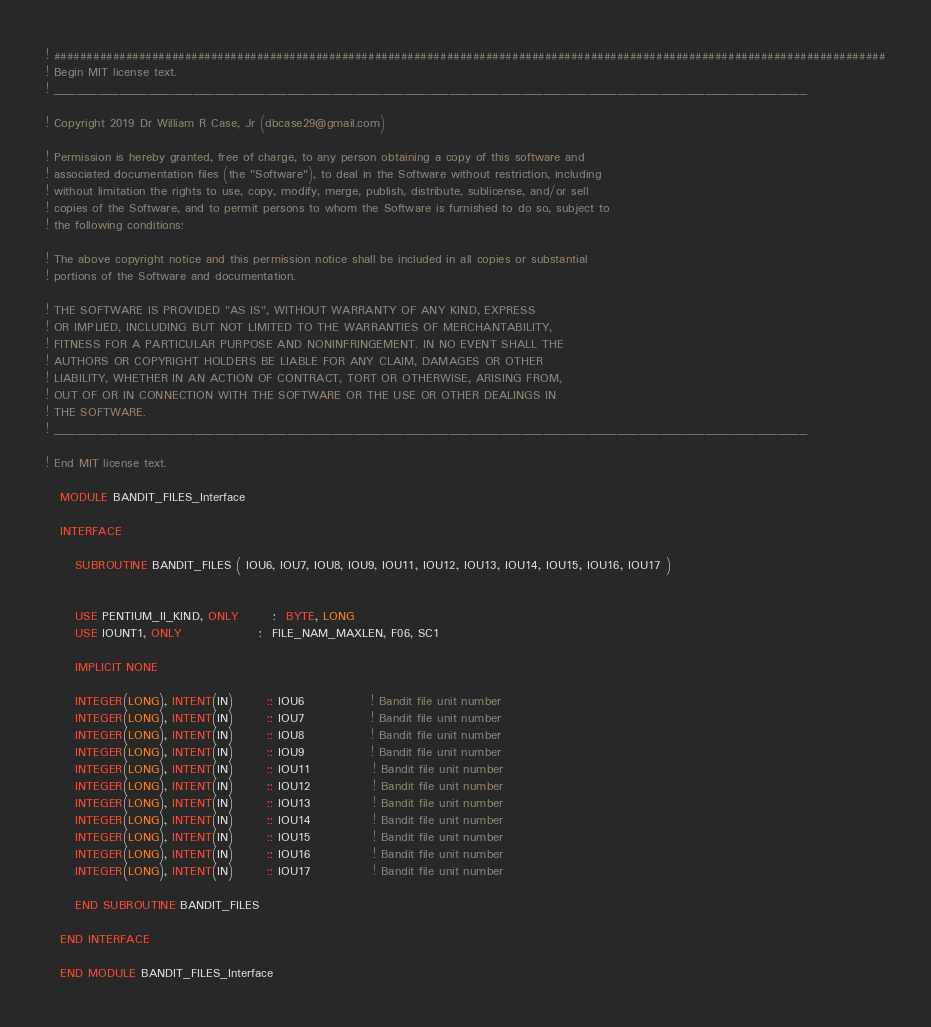Convert code to text. <code><loc_0><loc_0><loc_500><loc_500><_FORTRAN_>! ###############################################################################################################################
! Begin MIT license text.                                                                                    
! _______________________________________________________________________________________________________
                                                                                                         
! Copyright 2019 Dr William R Case, Jr (dbcase29@gmail.com)                                              
                                                                                                         
! Permission is hereby granted, free of charge, to any person obtaining a copy of this software and      
! associated documentation files (the "Software"), to deal in the Software without restriction, including
! without limitation the rights to use, copy, modify, merge, publish, distribute, sublicense, and/or sell
! copies of the Software, and to permit persons to whom the Software is furnished to do so, subject to   
! the following conditions:                                                                              
                                                                                                         
! The above copyright notice and this permission notice shall be included in all copies or substantial   
! portions of the Software and documentation.                                                                              
                                                                                                         
! THE SOFTWARE IS PROVIDED "AS IS", WITHOUT WARRANTY OF ANY KIND, EXPRESS                                
! OR IMPLIED, INCLUDING BUT NOT LIMITED TO THE WARRANTIES OF MERCHANTABILITY,                            
! FITNESS FOR A PARTICULAR PURPOSE AND NONINFRINGEMENT. IN NO EVENT SHALL THE                            
! AUTHORS OR COPYRIGHT HOLDERS BE LIABLE FOR ANY CLAIM, DAMAGES OR OTHER                                 
! LIABILITY, WHETHER IN AN ACTION OF CONTRACT, TORT OR OTHERWISE, ARISING FROM,                          
! OUT OF OR IN CONNECTION WITH THE SOFTWARE OR THE USE OR OTHER DEALINGS IN                              
! THE SOFTWARE.                                                                                          
! _______________________________________________________________________________________________________
                                                                                                        
! End MIT license text.                                                                                      

   MODULE BANDIT_FILES_Interface

   INTERFACE

      SUBROUTINE BANDIT_FILES ( IOU6, IOU7, IOU8, IOU9, IOU11, IOU12, IOU13, IOU14, IOU15, IOU16, IOU17 )

 
      USE PENTIUM_II_KIND, ONLY       :  BYTE, LONG
      USE IOUNT1, ONLY                :  FILE_NAM_MAXLEN, F06, SC1

      IMPLICIT NONE
 
      INTEGER(LONG), INTENT(IN)       :: IOU6              ! Bandit file unit number
      INTEGER(LONG), INTENT(IN)       :: IOU7              ! Bandit file unit number
      INTEGER(LONG), INTENT(IN)       :: IOU8              ! Bandit file unit number
      INTEGER(LONG), INTENT(IN)       :: IOU9              ! Bandit file unit number
      INTEGER(LONG), INTENT(IN)       :: IOU11             ! Bandit file unit number
      INTEGER(LONG), INTENT(IN)       :: IOU12             ! Bandit file unit number
      INTEGER(LONG), INTENT(IN)       :: IOU13             ! Bandit file unit number
      INTEGER(LONG), INTENT(IN)       :: IOU14             ! Bandit file unit number
      INTEGER(LONG), INTENT(IN)       :: IOU15             ! Bandit file unit number
      INTEGER(LONG), INTENT(IN)       :: IOU16             ! Bandit file unit number
      INTEGER(LONG), INTENT(IN)       :: IOU17             ! Bandit file unit number

      END SUBROUTINE BANDIT_FILES

   END INTERFACE

   END MODULE BANDIT_FILES_Interface

</code> 